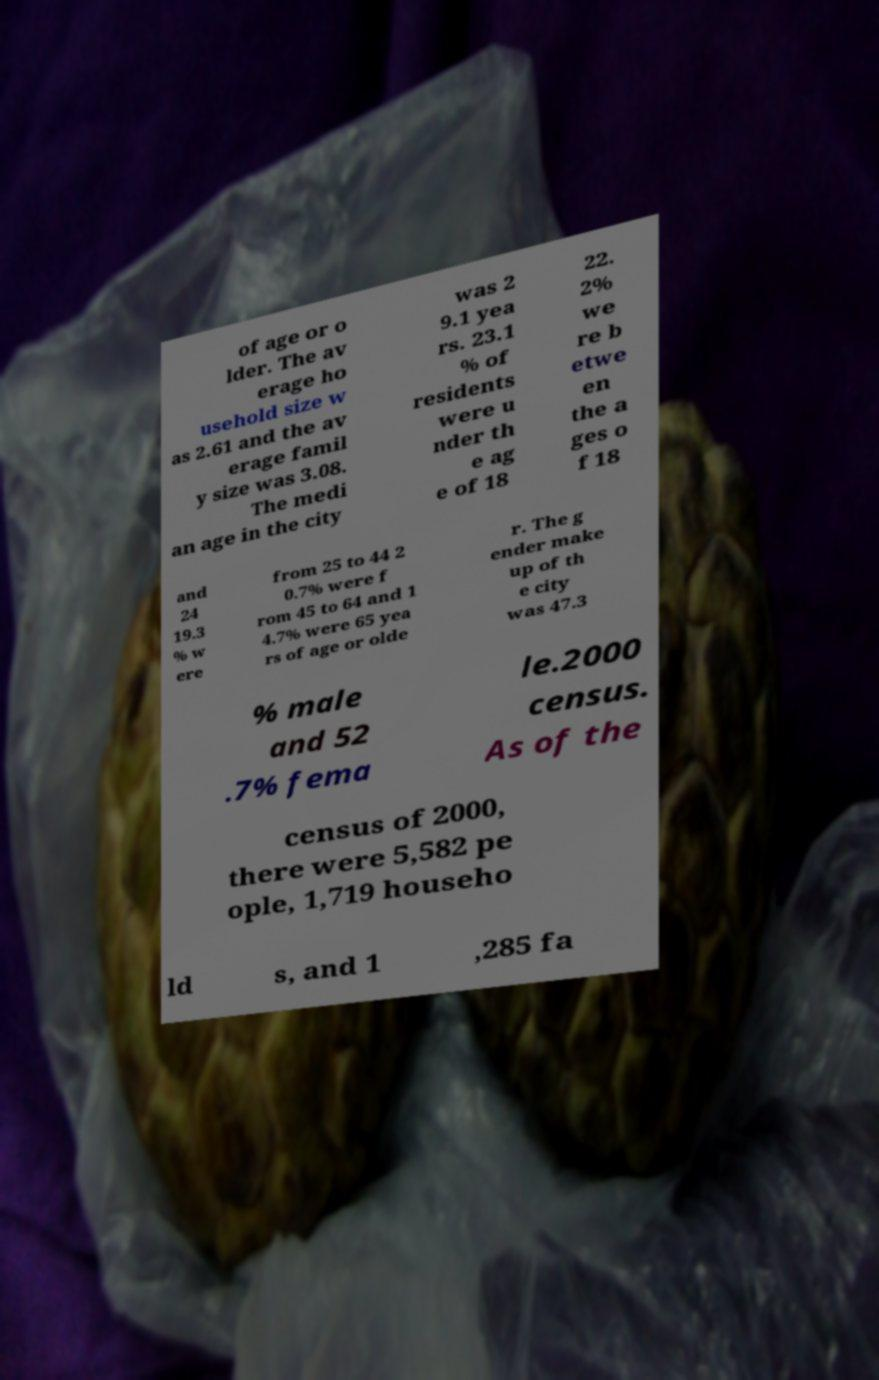For documentation purposes, I need the text within this image transcribed. Could you provide that? of age or o lder. The av erage ho usehold size w as 2.61 and the av erage famil y size was 3.08. The medi an age in the city was 2 9.1 yea rs. 23.1 % of residents were u nder th e ag e of 18 22. 2% we re b etwe en the a ges o f 18 and 24 19.3 % w ere from 25 to 44 2 0.7% were f rom 45 to 64 and 1 4.7% were 65 yea rs of age or olde r. The g ender make up of th e city was 47.3 % male and 52 .7% fema le.2000 census. As of the census of 2000, there were 5,582 pe ople, 1,719 househo ld s, and 1 ,285 fa 